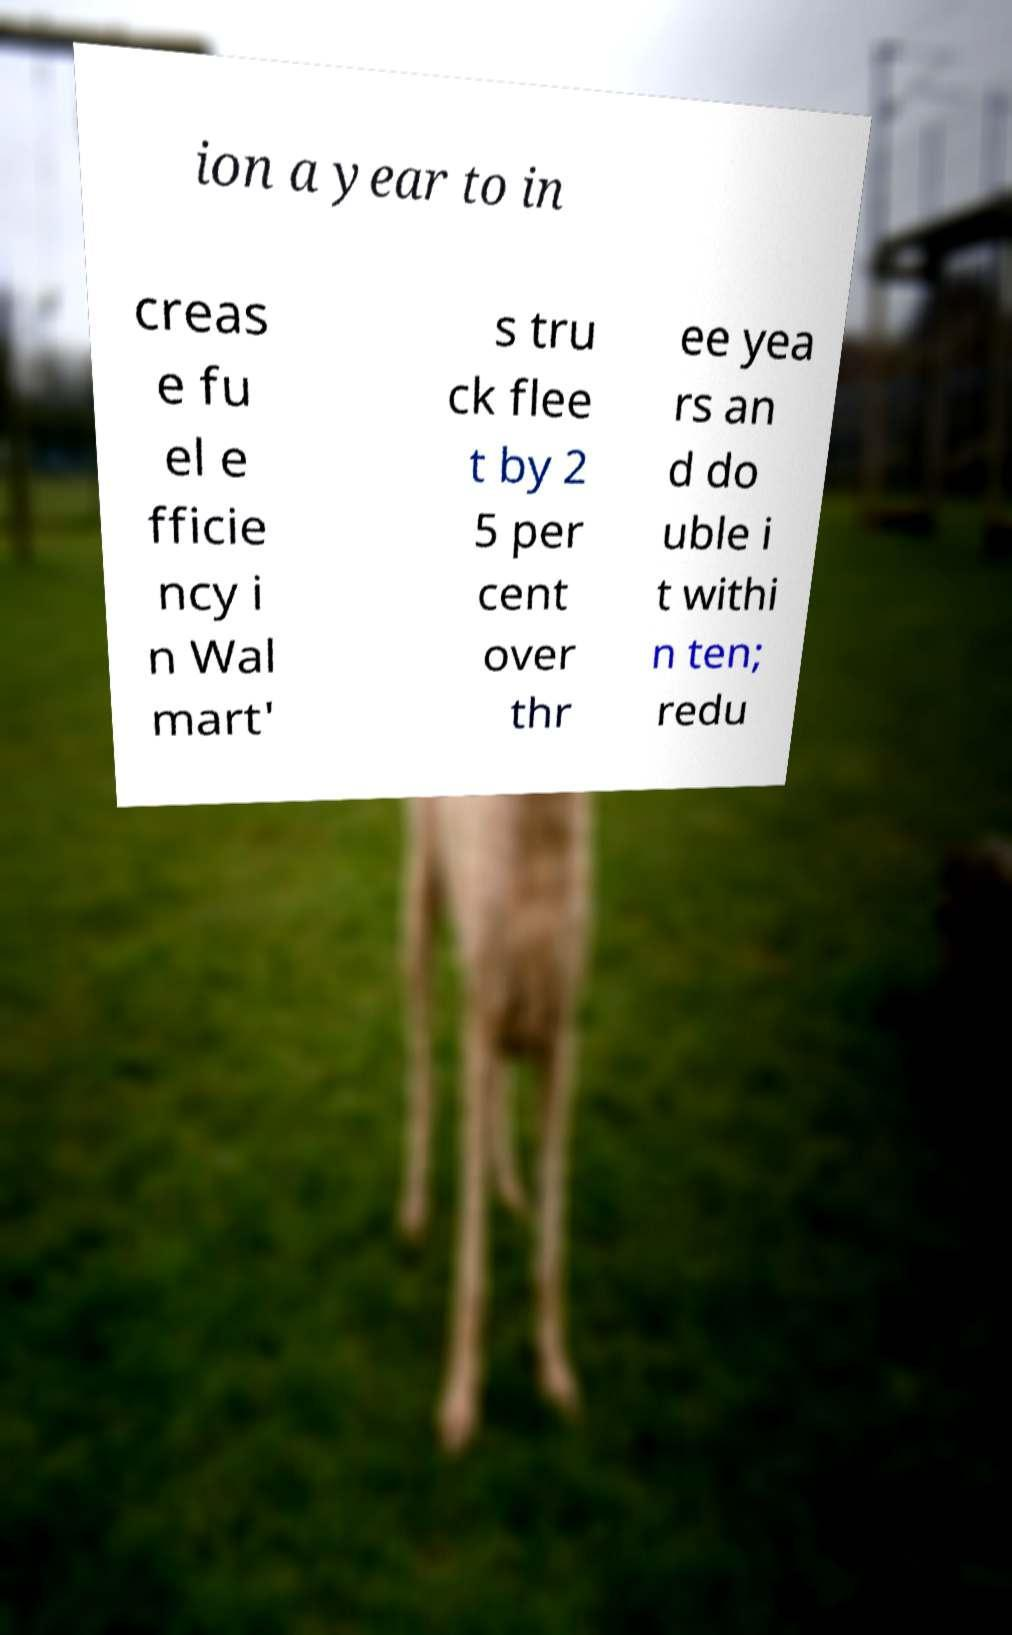I need the written content from this picture converted into text. Can you do that? ion a year to in creas e fu el e fficie ncy i n Wal mart' s tru ck flee t by 2 5 per cent over thr ee yea rs an d do uble i t withi n ten; redu 